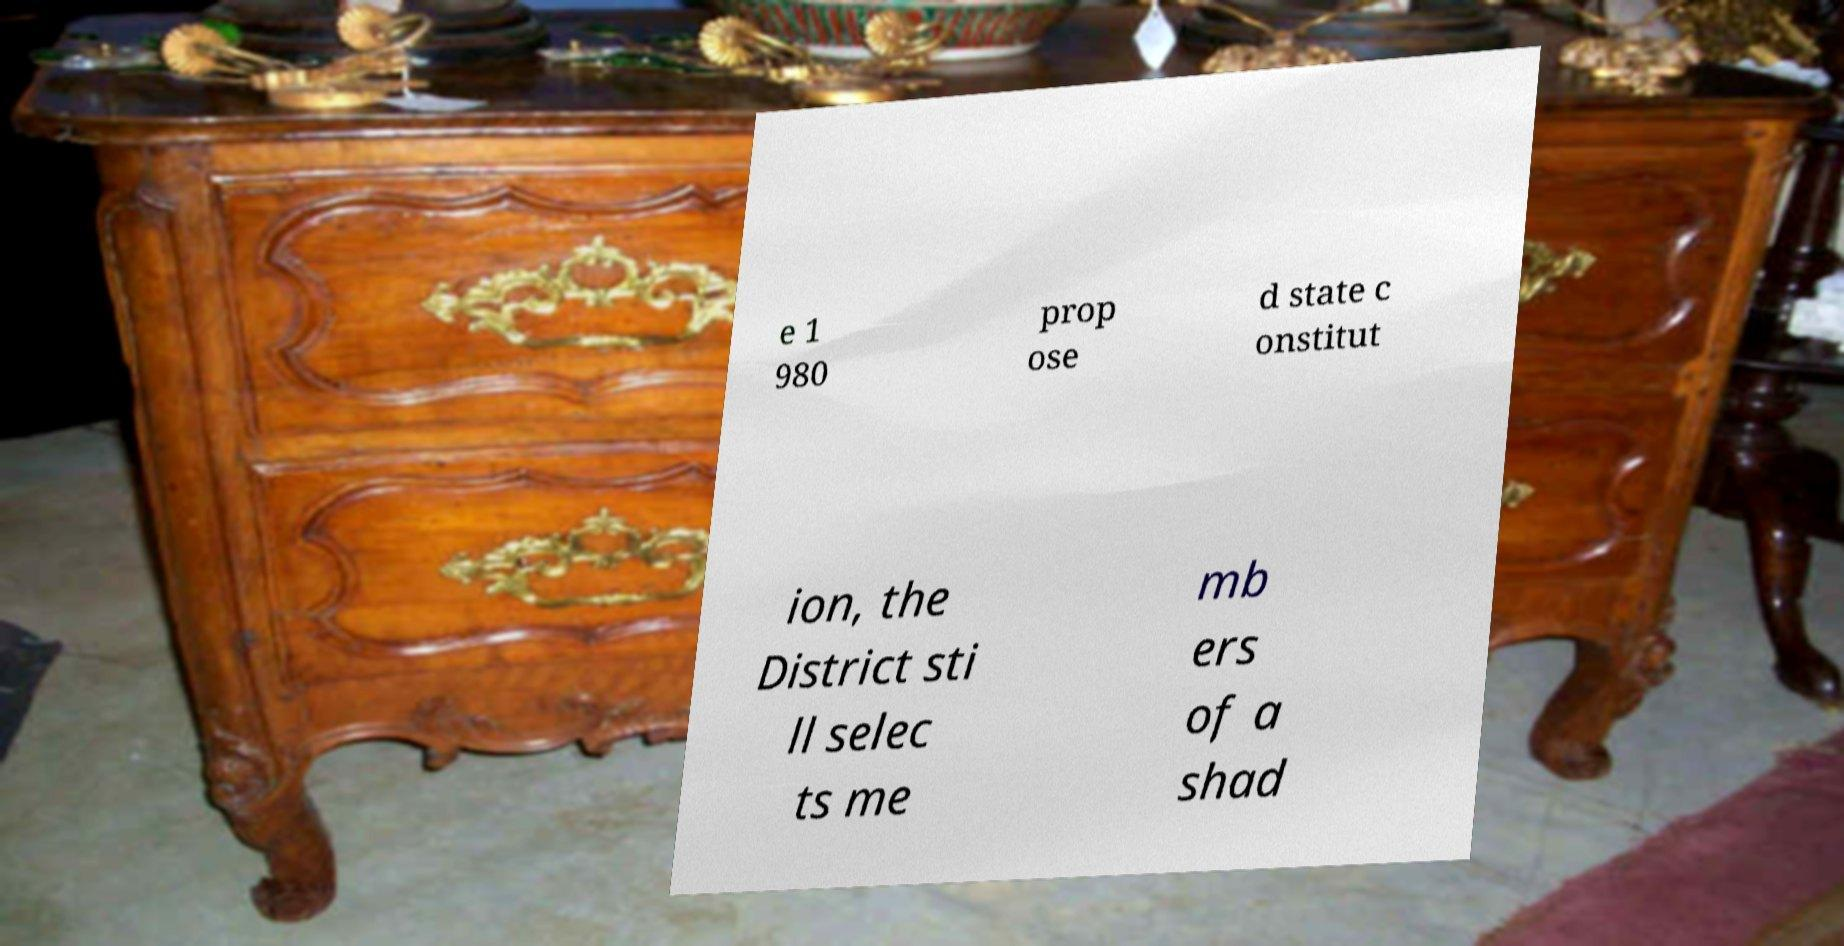Can you accurately transcribe the text from the provided image for me? e 1 980 prop ose d state c onstitut ion, the District sti ll selec ts me mb ers of a shad 